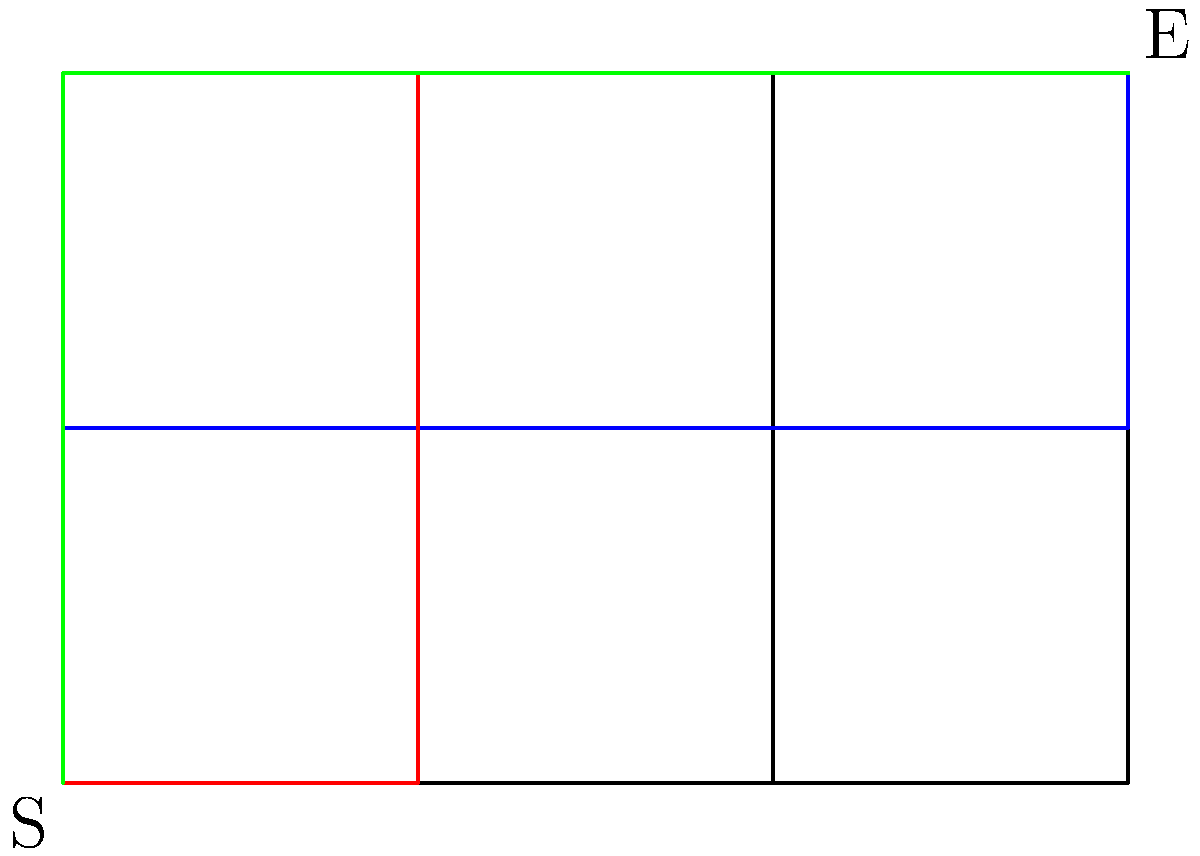In your indie game developed with MonoGame, you've designed a maze-like level represented by a $4 \times 3$ grid. The player starts at point S (bottom-left) and must reach point E (top-right). Movement is allowed only in the upward and rightward directions. How many different paths can the player take from S to E without crossing their own path? To solve this problem, we can use a combination of graph theory and combinatorics:

1. First, observe that any valid path from S to E must consist of exactly 3 upward moves and 3 rightward moves, regardless of the order.

2. The total number of moves is always 6 (3 up + 3 right).

3. This problem is equivalent to choosing the positions for either the upward or rightward moves among the 6 total moves.

4. We can use the combination formula to calculate this:

   $$\binom{6}{3} = \frac{6!}{3!(6-3)!} = \frac{6!}{3!3!}$$

5. Expanding this:
   $$\frac{6 \times 5 \times 4 \times 3!}{3 \times 2 \times 1 \times 3!} = \frac{6 \times 5 \times 4}{3 \times 2 \times 1} = \frac{120}{6} = 20$$

Therefore, there are 20 different paths the player can take from S to E without crossing their own path.

This solution applies to any rectangular grid where diagonal movement is not allowed, making it useful for various maze-like level designs in your indie game.
Answer: 20 paths 